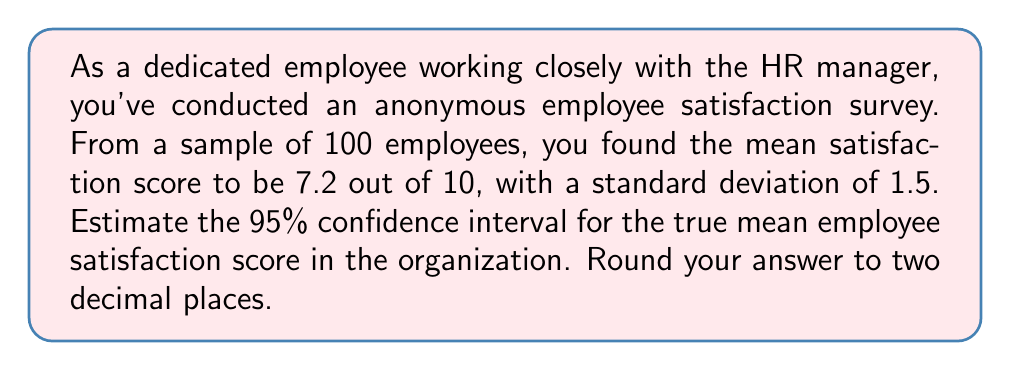Can you solve this math problem? To calculate the confidence interval for the mean employee satisfaction score, we'll use the formula:

$$ \text{CI} = \bar{x} \pm t_{\alpha/2} \cdot \frac{s}{\sqrt{n}} $$

Where:
- $\bar{x}$ is the sample mean (7.2)
- $s$ is the sample standard deviation (1.5)
- $n$ is the sample size (100)
- $t_{\alpha/2}$ is the t-value for a 95% confidence interval with 99 degrees of freedom

Steps:
1) For a 95% CI with 99 degrees of freedom, $t_{\alpha/2} \approx 1.984$ (from t-distribution table)

2) Calculate the standard error of the mean:
   $$ SE = \frac{s}{\sqrt{n}} = \frac{1.5}{\sqrt{100}} = 0.15 $$

3) Calculate the margin of error:
   $$ ME = t_{\alpha/2} \cdot SE = 1.984 \cdot 0.15 = 0.2976 $$

4) Calculate the confidence interval:
   $$ \text{CI} = 7.2 \pm 0.2976 $$
   $$ \text{Lower bound} = 7.2 - 0.2976 = 6.9024 $$
   $$ \text{Upper bound} = 7.2 + 0.2976 = 7.4976 $$

5) Round to two decimal places:
   $$ \text{CI} = (6.90, 7.50) $$
Answer: The 95% confidence interval for the true mean employee satisfaction score is (6.90, 7.50). 